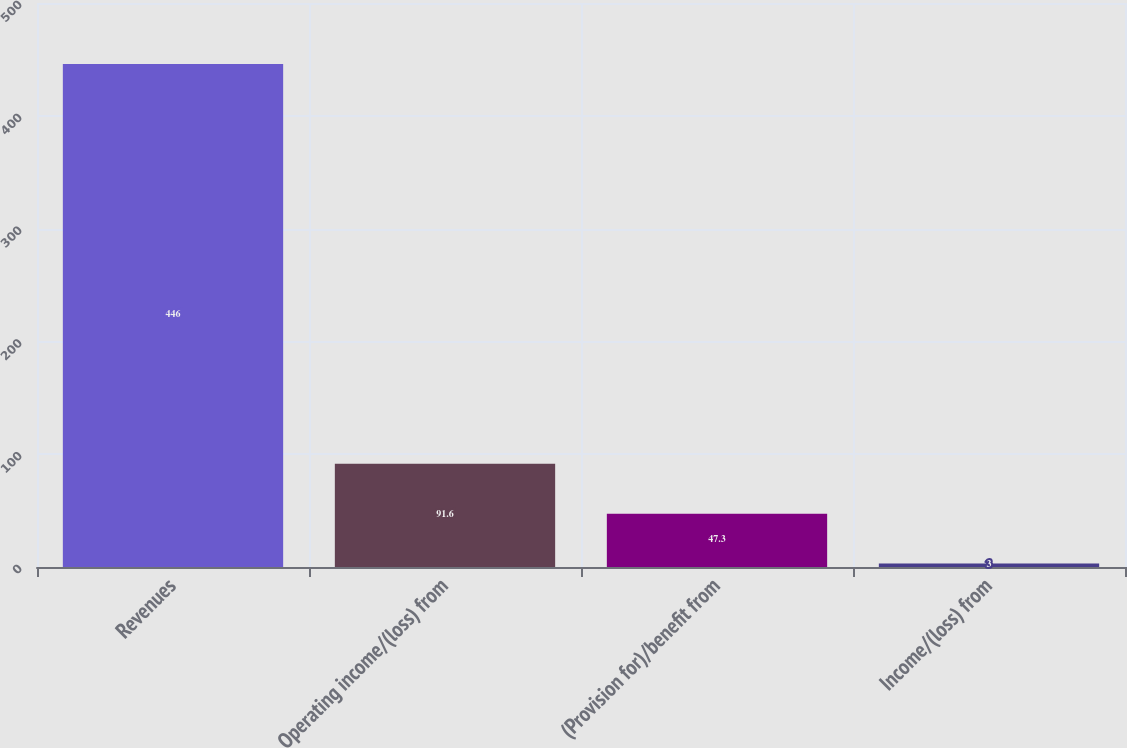<chart> <loc_0><loc_0><loc_500><loc_500><bar_chart><fcel>Revenues<fcel>Operating income/(loss) from<fcel>(Provision for)/benefit from<fcel>Income/(loss) from<nl><fcel>446<fcel>91.6<fcel>47.3<fcel>3<nl></chart> 